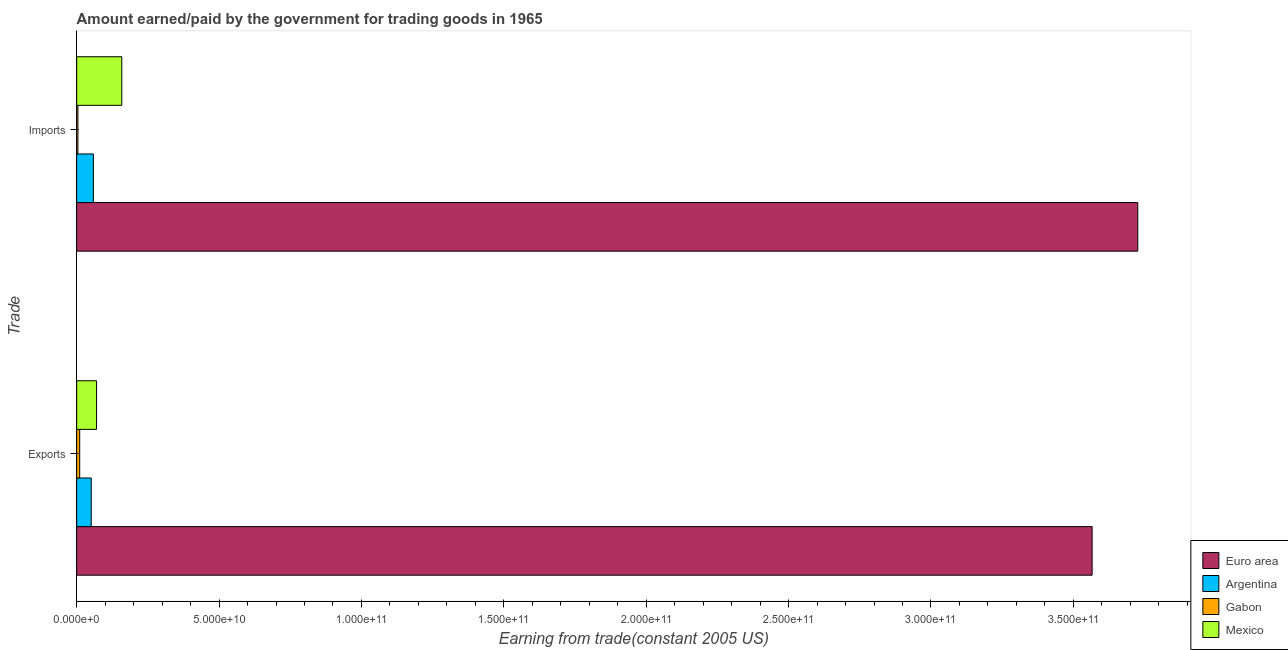How many different coloured bars are there?
Your answer should be compact. 4. Are the number of bars per tick equal to the number of legend labels?
Ensure brevity in your answer.  Yes. How many bars are there on the 1st tick from the top?
Your answer should be compact. 4. What is the label of the 2nd group of bars from the top?
Provide a short and direct response. Exports. What is the amount paid for imports in Argentina?
Your answer should be very brief. 5.87e+09. Across all countries, what is the maximum amount earned from exports?
Keep it short and to the point. 3.57e+11. Across all countries, what is the minimum amount paid for imports?
Offer a very short reply. 4.46e+08. In which country was the amount earned from exports maximum?
Give a very brief answer. Euro area. In which country was the amount earned from exports minimum?
Keep it short and to the point. Gabon. What is the total amount earned from exports in the graph?
Offer a terse response. 3.70e+11. What is the difference between the amount paid for imports in Euro area and that in Argentina?
Keep it short and to the point. 3.67e+11. What is the difference between the amount paid for imports in Euro area and the amount earned from exports in Gabon?
Provide a succinct answer. 3.72e+11. What is the average amount earned from exports per country?
Make the answer very short. 9.24e+1. What is the difference between the amount earned from exports and amount paid for imports in Euro area?
Provide a short and direct response. -1.60e+1. What is the ratio of the amount earned from exports in Euro area to that in Mexico?
Offer a terse response. 51.02. Is the amount paid for imports in Argentina less than that in Gabon?
Give a very brief answer. No. In how many countries, is the amount earned from exports greater than the average amount earned from exports taken over all countries?
Offer a very short reply. 1. What does the 3rd bar from the top in Imports represents?
Give a very brief answer. Argentina. What does the 1st bar from the bottom in Imports represents?
Your answer should be compact. Euro area. How many bars are there?
Provide a short and direct response. 8. Are all the bars in the graph horizontal?
Offer a terse response. Yes. How many countries are there in the graph?
Your response must be concise. 4. What is the difference between two consecutive major ticks on the X-axis?
Ensure brevity in your answer.  5.00e+1. Does the graph contain any zero values?
Your response must be concise. No. What is the title of the graph?
Offer a terse response. Amount earned/paid by the government for trading goods in 1965. Does "Cyprus" appear as one of the legend labels in the graph?
Ensure brevity in your answer.  No. What is the label or title of the X-axis?
Offer a terse response. Earning from trade(constant 2005 US). What is the label or title of the Y-axis?
Keep it short and to the point. Trade. What is the Earning from trade(constant 2005 US) of Euro area in Exports?
Your response must be concise. 3.57e+11. What is the Earning from trade(constant 2005 US) of Argentina in Exports?
Make the answer very short. 5.12e+09. What is the Earning from trade(constant 2005 US) of Gabon in Exports?
Provide a short and direct response. 1.07e+09. What is the Earning from trade(constant 2005 US) in Mexico in Exports?
Provide a short and direct response. 6.99e+09. What is the Earning from trade(constant 2005 US) of Euro area in Imports?
Offer a terse response. 3.73e+11. What is the Earning from trade(constant 2005 US) of Argentina in Imports?
Provide a succinct answer. 5.87e+09. What is the Earning from trade(constant 2005 US) in Gabon in Imports?
Offer a terse response. 4.46e+08. What is the Earning from trade(constant 2005 US) in Mexico in Imports?
Your response must be concise. 1.58e+1. Across all Trade, what is the maximum Earning from trade(constant 2005 US) in Euro area?
Provide a short and direct response. 3.73e+11. Across all Trade, what is the maximum Earning from trade(constant 2005 US) in Argentina?
Give a very brief answer. 5.87e+09. Across all Trade, what is the maximum Earning from trade(constant 2005 US) in Gabon?
Keep it short and to the point. 1.07e+09. Across all Trade, what is the maximum Earning from trade(constant 2005 US) in Mexico?
Provide a succinct answer. 1.58e+1. Across all Trade, what is the minimum Earning from trade(constant 2005 US) in Euro area?
Your response must be concise. 3.57e+11. Across all Trade, what is the minimum Earning from trade(constant 2005 US) in Argentina?
Ensure brevity in your answer.  5.12e+09. Across all Trade, what is the minimum Earning from trade(constant 2005 US) of Gabon?
Your answer should be very brief. 4.46e+08. Across all Trade, what is the minimum Earning from trade(constant 2005 US) in Mexico?
Ensure brevity in your answer.  6.99e+09. What is the total Earning from trade(constant 2005 US) in Euro area in the graph?
Keep it short and to the point. 7.29e+11. What is the total Earning from trade(constant 2005 US) of Argentina in the graph?
Your answer should be very brief. 1.10e+1. What is the total Earning from trade(constant 2005 US) in Gabon in the graph?
Ensure brevity in your answer.  1.52e+09. What is the total Earning from trade(constant 2005 US) of Mexico in the graph?
Give a very brief answer. 2.28e+1. What is the difference between the Earning from trade(constant 2005 US) in Euro area in Exports and that in Imports?
Keep it short and to the point. -1.60e+1. What is the difference between the Earning from trade(constant 2005 US) of Argentina in Exports and that in Imports?
Your answer should be compact. -7.52e+08. What is the difference between the Earning from trade(constant 2005 US) of Gabon in Exports and that in Imports?
Make the answer very short. 6.24e+08. What is the difference between the Earning from trade(constant 2005 US) of Mexico in Exports and that in Imports?
Offer a very short reply. -8.85e+09. What is the difference between the Earning from trade(constant 2005 US) of Euro area in Exports and the Earning from trade(constant 2005 US) of Argentina in Imports?
Your answer should be compact. 3.51e+11. What is the difference between the Earning from trade(constant 2005 US) of Euro area in Exports and the Earning from trade(constant 2005 US) of Gabon in Imports?
Give a very brief answer. 3.56e+11. What is the difference between the Earning from trade(constant 2005 US) in Euro area in Exports and the Earning from trade(constant 2005 US) in Mexico in Imports?
Your response must be concise. 3.41e+11. What is the difference between the Earning from trade(constant 2005 US) of Argentina in Exports and the Earning from trade(constant 2005 US) of Gabon in Imports?
Provide a short and direct response. 4.67e+09. What is the difference between the Earning from trade(constant 2005 US) in Argentina in Exports and the Earning from trade(constant 2005 US) in Mexico in Imports?
Offer a very short reply. -1.07e+1. What is the difference between the Earning from trade(constant 2005 US) of Gabon in Exports and the Earning from trade(constant 2005 US) of Mexico in Imports?
Give a very brief answer. -1.48e+1. What is the average Earning from trade(constant 2005 US) in Euro area per Trade?
Your response must be concise. 3.65e+11. What is the average Earning from trade(constant 2005 US) in Argentina per Trade?
Offer a terse response. 5.49e+09. What is the average Earning from trade(constant 2005 US) in Gabon per Trade?
Your answer should be compact. 7.58e+08. What is the average Earning from trade(constant 2005 US) of Mexico per Trade?
Your answer should be compact. 1.14e+1. What is the difference between the Earning from trade(constant 2005 US) in Euro area and Earning from trade(constant 2005 US) in Argentina in Exports?
Make the answer very short. 3.51e+11. What is the difference between the Earning from trade(constant 2005 US) of Euro area and Earning from trade(constant 2005 US) of Gabon in Exports?
Give a very brief answer. 3.56e+11. What is the difference between the Earning from trade(constant 2005 US) of Euro area and Earning from trade(constant 2005 US) of Mexico in Exports?
Make the answer very short. 3.50e+11. What is the difference between the Earning from trade(constant 2005 US) of Argentina and Earning from trade(constant 2005 US) of Gabon in Exports?
Your response must be concise. 4.05e+09. What is the difference between the Earning from trade(constant 2005 US) in Argentina and Earning from trade(constant 2005 US) in Mexico in Exports?
Give a very brief answer. -1.87e+09. What is the difference between the Earning from trade(constant 2005 US) of Gabon and Earning from trade(constant 2005 US) of Mexico in Exports?
Provide a succinct answer. -5.92e+09. What is the difference between the Earning from trade(constant 2005 US) in Euro area and Earning from trade(constant 2005 US) in Argentina in Imports?
Keep it short and to the point. 3.67e+11. What is the difference between the Earning from trade(constant 2005 US) in Euro area and Earning from trade(constant 2005 US) in Gabon in Imports?
Provide a succinct answer. 3.72e+11. What is the difference between the Earning from trade(constant 2005 US) of Euro area and Earning from trade(constant 2005 US) of Mexico in Imports?
Offer a terse response. 3.57e+11. What is the difference between the Earning from trade(constant 2005 US) of Argentina and Earning from trade(constant 2005 US) of Gabon in Imports?
Provide a short and direct response. 5.42e+09. What is the difference between the Earning from trade(constant 2005 US) of Argentina and Earning from trade(constant 2005 US) of Mexico in Imports?
Keep it short and to the point. -9.97e+09. What is the difference between the Earning from trade(constant 2005 US) in Gabon and Earning from trade(constant 2005 US) in Mexico in Imports?
Ensure brevity in your answer.  -1.54e+1. What is the ratio of the Earning from trade(constant 2005 US) of Argentina in Exports to that in Imports?
Your answer should be very brief. 0.87. What is the ratio of the Earning from trade(constant 2005 US) of Gabon in Exports to that in Imports?
Offer a terse response. 2.4. What is the ratio of the Earning from trade(constant 2005 US) in Mexico in Exports to that in Imports?
Your response must be concise. 0.44. What is the difference between the highest and the second highest Earning from trade(constant 2005 US) of Euro area?
Ensure brevity in your answer.  1.60e+1. What is the difference between the highest and the second highest Earning from trade(constant 2005 US) in Argentina?
Offer a very short reply. 7.52e+08. What is the difference between the highest and the second highest Earning from trade(constant 2005 US) in Gabon?
Keep it short and to the point. 6.24e+08. What is the difference between the highest and the second highest Earning from trade(constant 2005 US) in Mexico?
Offer a terse response. 8.85e+09. What is the difference between the highest and the lowest Earning from trade(constant 2005 US) in Euro area?
Your answer should be compact. 1.60e+1. What is the difference between the highest and the lowest Earning from trade(constant 2005 US) of Argentina?
Make the answer very short. 7.52e+08. What is the difference between the highest and the lowest Earning from trade(constant 2005 US) of Gabon?
Provide a succinct answer. 6.24e+08. What is the difference between the highest and the lowest Earning from trade(constant 2005 US) of Mexico?
Provide a short and direct response. 8.85e+09. 